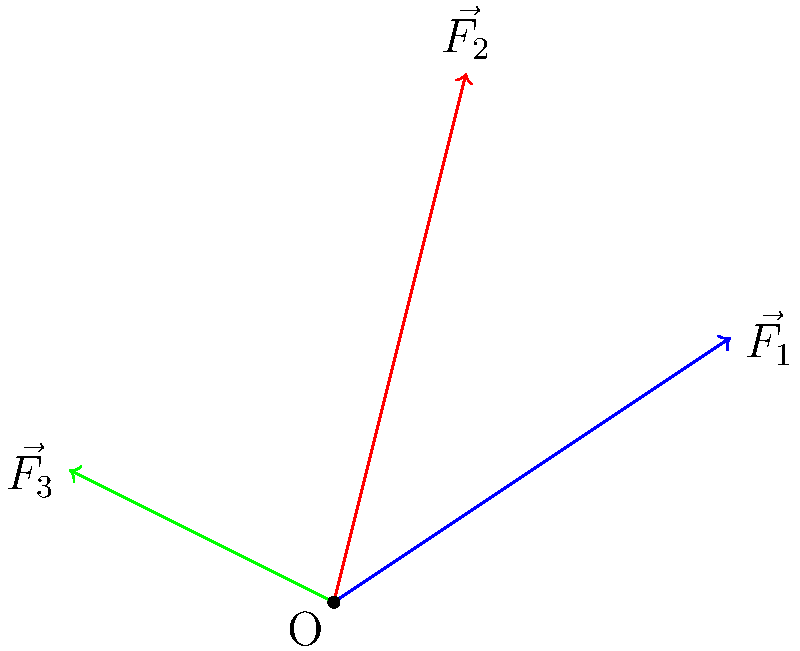In your latest comic, a villain's doomsday device is subjected to three force vectors: $\vec{F_1} = 3\hat{i} + 2\hat{j}$, $\vec{F_2} = \hat{i} + 4\hat{j}$, and $\vec{F_3} = -2\hat{i} + \hat{j}$. Calculate the magnitude of the resultant force vector acting on the device. To find the magnitude of the resultant force vector, we'll follow these steps:

1) First, we need to add all the force vectors to get the resultant force vector $\vec{R}$:

   $\vec{R} = \vec{F_1} + \vec{F_2} + \vec{F_3}$

2) Let's add the components:
   
   $\vec{R} = (3\hat{i} + 2\hat{j}) + (\hat{i} + 4\hat{j}) + (-2\hat{i} + \hat{j})$
   
   $\vec{R} = (3 + 1 - 2)\hat{i} + (2 + 4 + 1)\hat{j}$
   
   $\vec{R} = 2\hat{i} + 7\hat{j}$

3) Now that we have the resultant vector, we can calculate its magnitude using the Pythagorean theorem:

   $|\vec{R}| = \sqrt{(2)^2 + (7)^2}$

4) Simplify:
   
   $|\vec{R}| = \sqrt{4 + 49} = \sqrt{53}$

Therefore, the magnitude of the resultant force vector is $\sqrt{53}$ units.
Answer: $\sqrt{53}$ units 